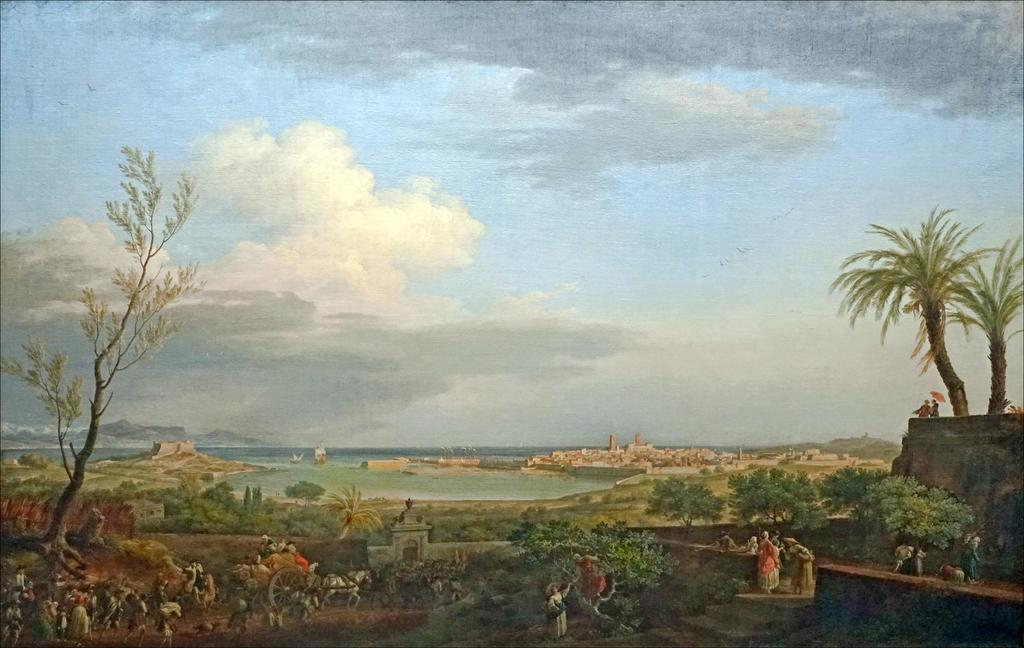What type of scene is depicted in the image? The image is a depiction of a scene. Can you describe the people in the image? There are people in the image. What object is present in the image that is used for transportation? There is a cart in the image, which is used for transportation. How is the cart being pulled in the image? The cart is tied to a horse in the image. What type of vegetation can be seen in the image? There are trees in the image. What is visible in the background of the image? The sky is visible in the image, and it has clouds. What songs are the people singing in the image? There is no indication in the image that the people are singing songs, so it cannot be determined from the picture. 